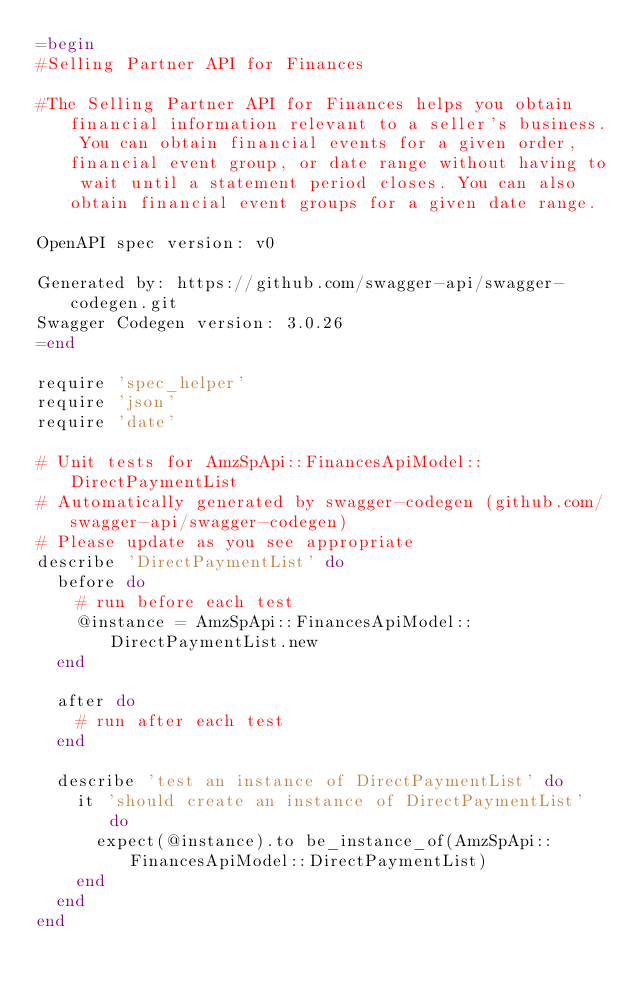<code> <loc_0><loc_0><loc_500><loc_500><_Ruby_>=begin
#Selling Partner API for Finances

#The Selling Partner API for Finances helps you obtain financial information relevant to a seller's business. You can obtain financial events for a given order, financial event group, or date range without having to wait until a statement period closes. You can also obtain financial event groups for a given date range.

OpenAPI spec version: v0

Generated by: https://github.com/swagger-api/swagger-codegen.git
Swagger Codegen version: 3.0.26
=end

require 'spec_helper'
require 'json'
require 'date'

# Unit tests for AmzSpApi::FinancesApiModel::DirectPaymentList
# Automatically generated by swagger-codegen (github.com/swagger-api/swagger-codegen)
# Please update as you see appropriate
describe 'DirectPaymentList' do
  before do
    # run before each test
    @instance = AmzSpApi::FinancesApiModel::DirectPaymentList.new
  end

  after do
    # run after each test
  end

  describe 'test an instance of DirectPaymentList' do
    it 'should create an instance of DirectPaymentList' do
      expect(@instance).to be_instance_of(AmzSpApi::FinancesApiModel::DirectPaymentList)
    end
  end
end
</code> 